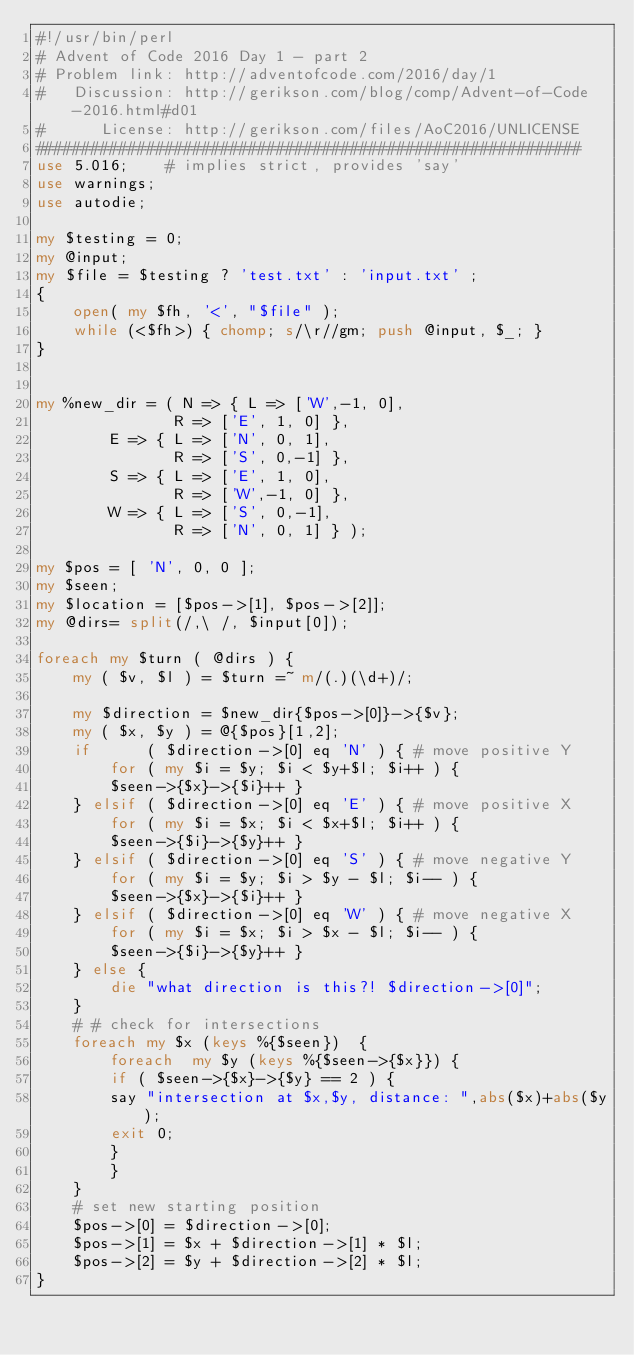Convert code to text. <code><loc_0><loc_0><loc_500><loc_500><_Perl_>#!/usr/bin/perl
# Advent of Code 2016 Day 1 - part 2
# Problem link: http://adventofcode.com/2016/day/1
#   Discussion: http://gerikson.com/blog/comp/Advent-of-Code-2016.html#d01
#      License: http://gerikson.com/files/AoC2016/UNLICENSE
###########################################################
use 5.016;    # implies strict, provides 'say'
use warnings;
use autodie;

my $testing = 0;
my @input;
my $file = $testing ? 'test.txt' : 'input.txt' ;
{
    open( my $fh, '<', "$file" );
    while (<$fh>) { chomp; s/\r//gm; push @input, $_; }
}


my %new_dir = ( N => { L => ['W',-1, 0],
		       R => ['E', 1, 0] },
		E => { L => ['N', 0, 1],
		       R => ['S', 0,-1] },
		S => { L => ['E', 1, 0],
		       R => ['W',-1, 0] },
		W => { L => ['S', 0,-1],
		       R => ['N', 0, 1] } );

my $pos = [ 'N', 0, 0 ];
my $seen;
my $location = [$pos->[1], $pos->[2]];
my @dirs= split(/,\ /, $input[0]);

foreach my $turn ( @dirs ) {
    my ( $v, $l ) = $turn =~ m/(.)(\d+)/;

    my $direction = $new_dir{$pos->[0]}->{$v};
    my ( $x, $y ) = @{$pos}[1,2];
    if      ( $direction->[0] eq 'N' ) { # move positive Y
    	for ( my $i = $y; $i < $y+$l; $i++ ) {
	    $seen->{$x}->{$i}++ }
    } elsif ( $direction->[0] eq 'E' ) { # move positive X
    	for ( my $i = $x; $i < $x+$l; $i++ ) {
	    $seen->{$i}->{$y}++ }
    } elsif ( $direction->[0] eq 'S' ) { # move negative Y
    	for ( my $i = $y; $i > $y - $l; $i-- ) {
	    $seen->{$x}->{$i}++ }
    } elsif ( $direction->[0] eq 'W' ) { # move negative X
    	for ( my $i = $x; $i > $x - $l; $i-- ) {
	    $seen->{$i}->{$y}++ }
    } else {
    	die "what direction is this?! $direction->[0]";
    }
    # # check for intersections
    foreach my $x (keys %{$seen})  {
    	foreach  my $y (keys %{$seen->{$x}}) {
	    if ( $seen->{$x}->{$y} == 2 ) { 
		say "intersection at $x,$y, distance: ",abs($x)+abs($y);
		exit 0;
	    }
    	}
    }
    # set new starting position
    $pos->[0] = $direction->[0];
    $pos->[1] = $x + $direction->[1] * $l;
    $pos->[2] = $y + $direction->[2] * $l;
}

</code> 